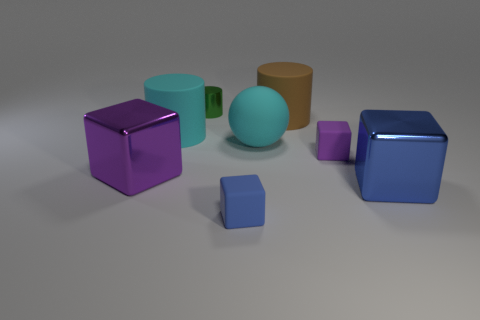Subtract all blue cubes. How many were subtracted if there are1blue cubes left? 1 Add 2 purple rubber blocks. How many objects exist? 10 Subtract all cylinders. How many objects are left? 5 Add 7 brown cylinders. How many brown cylinders exist? 8 Subtract 0 blue spheres. How many objects are left? 8 Subtract all large cyan rubber objects. Subtract all large brown objects. How many objects are left? 5 Add 1 blue metal blocks. How many blue metal blocks are left? 2 